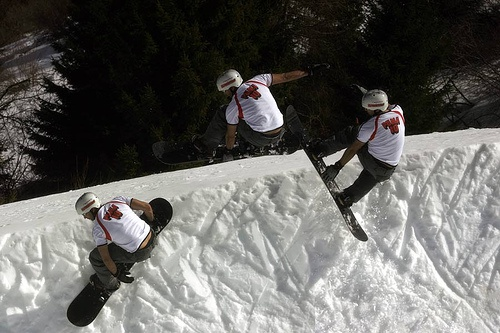Describe the objects in this image and their specific colors. I can see people in black, gray, lightgray, and darkgray tones, people in black, darkgray, gray, and lightgray tones, people in black, darkgray, lightgray, and gray tones, snowboard in black, gray, darkgray, and maroon tones, and snowboard in black, gray, and darkgray tones in this image. 